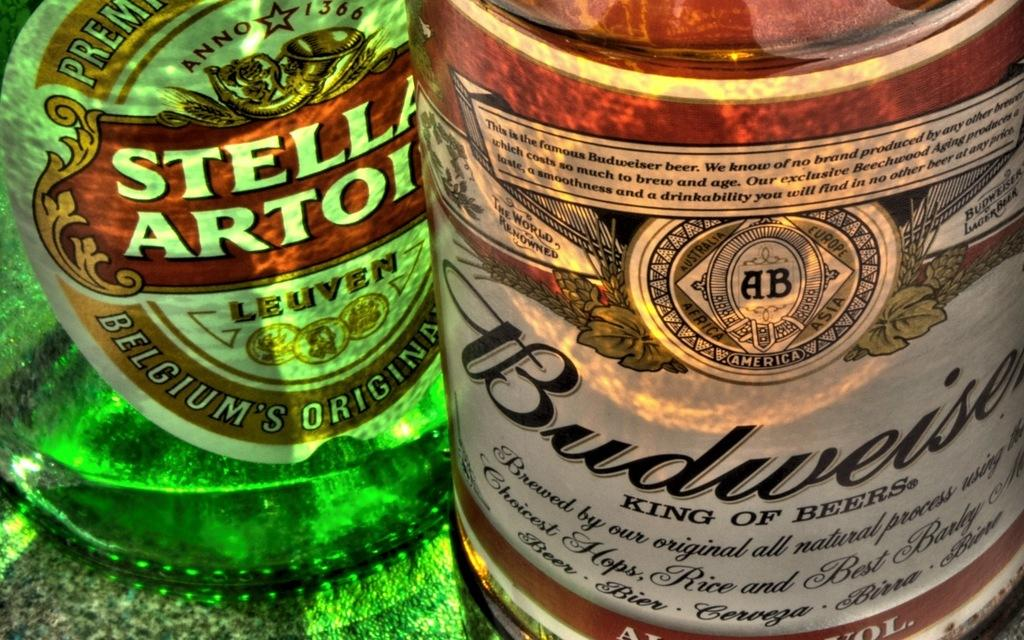<image>
Describe the image concisely. bottle of budweiser king of beers that is standing in front of a green bottle 